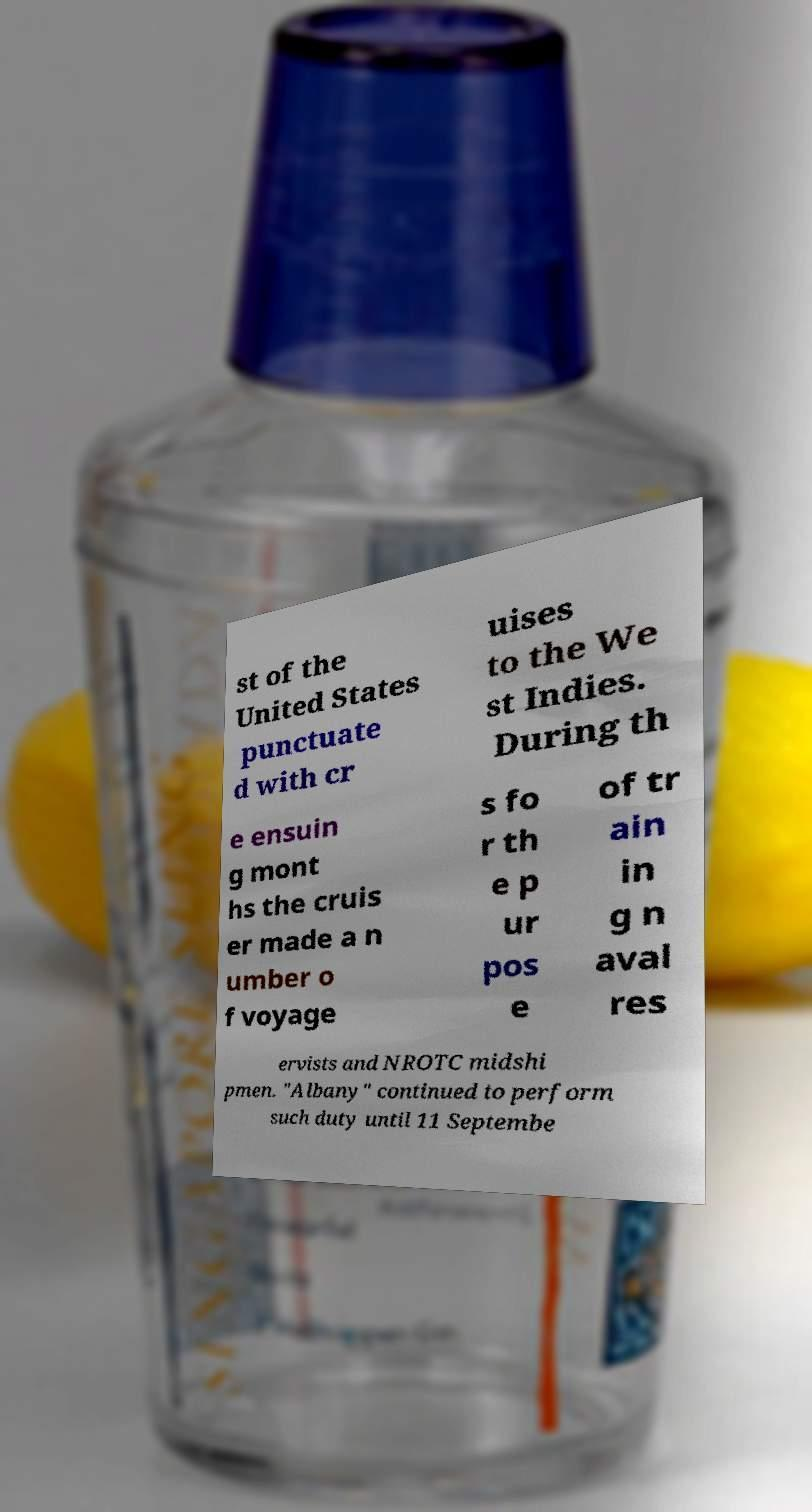Can you read and provide the text displayed in the image?This photo seems to have some interesting text. Can you extract and type it out for me? st of the United States punctuate d with cr uises to the We st Indies. During th e ensuin g mont hs the cruis er made a n umber o f voyage s fo r th e p ur pos e of tr ain in g n aval res ervists and NROTC midshi pmen. "Albany" continued to perform such duty until 11 Septembe 